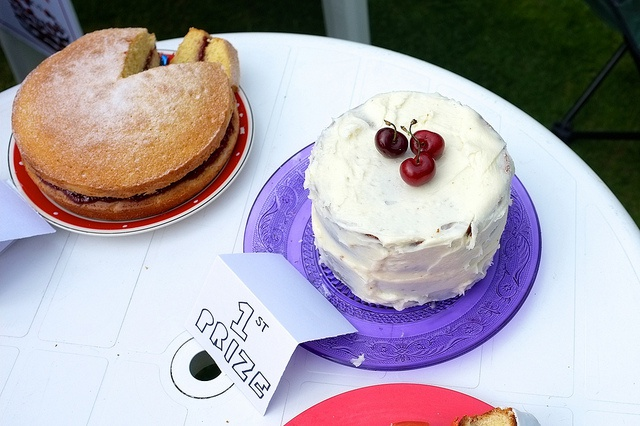Describe the objects in this image and their specific colors. I can see dining table in white, navy, darkgray, lavender, and tan tones, cake in navy, ivory, darkgray, maroon, and lightgray tones, and cake in navy, tan, lightgray, and brown tones in this image. 